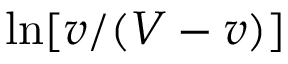Convert formula to latex. <formula><loc_0><loc_0><loc_500><loc_500>\ln [ v / ( V - v ) ]</formula> 